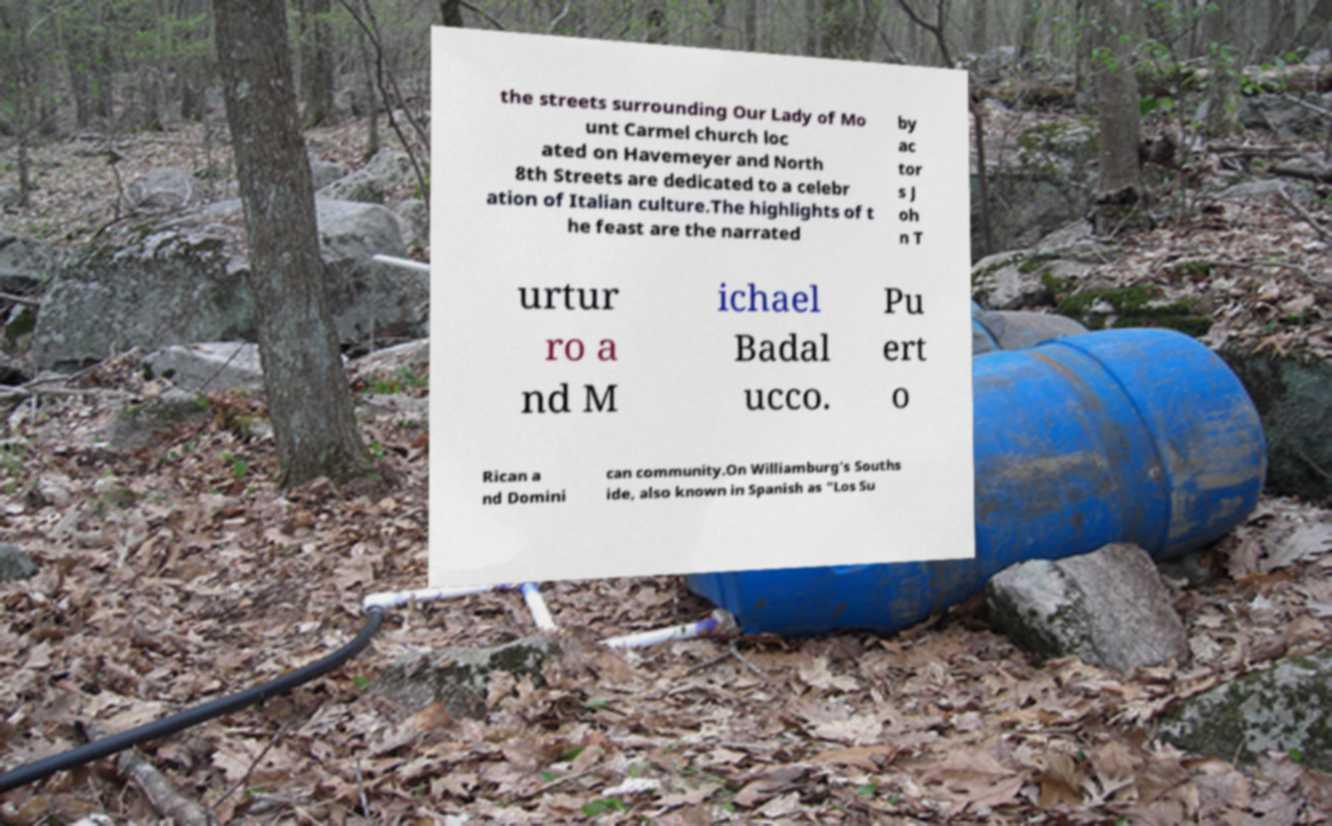For documentation purposes, I need the text within this image transcribed. Could you provide that? the streets surrounding Our Lady of Mo unt Carmel church loc ated on Havemeyer and North 8th Streets are dedicated to a celebr ation of Italian culture.The highlights of t he feast are the narrated by ac tor s J oh n T urtur ro a nd M ichael Badal ucco. Pu ert o Rican a nd Domini can community.On Williamburg's Souths ide, also known in Spanish as "Los Su 